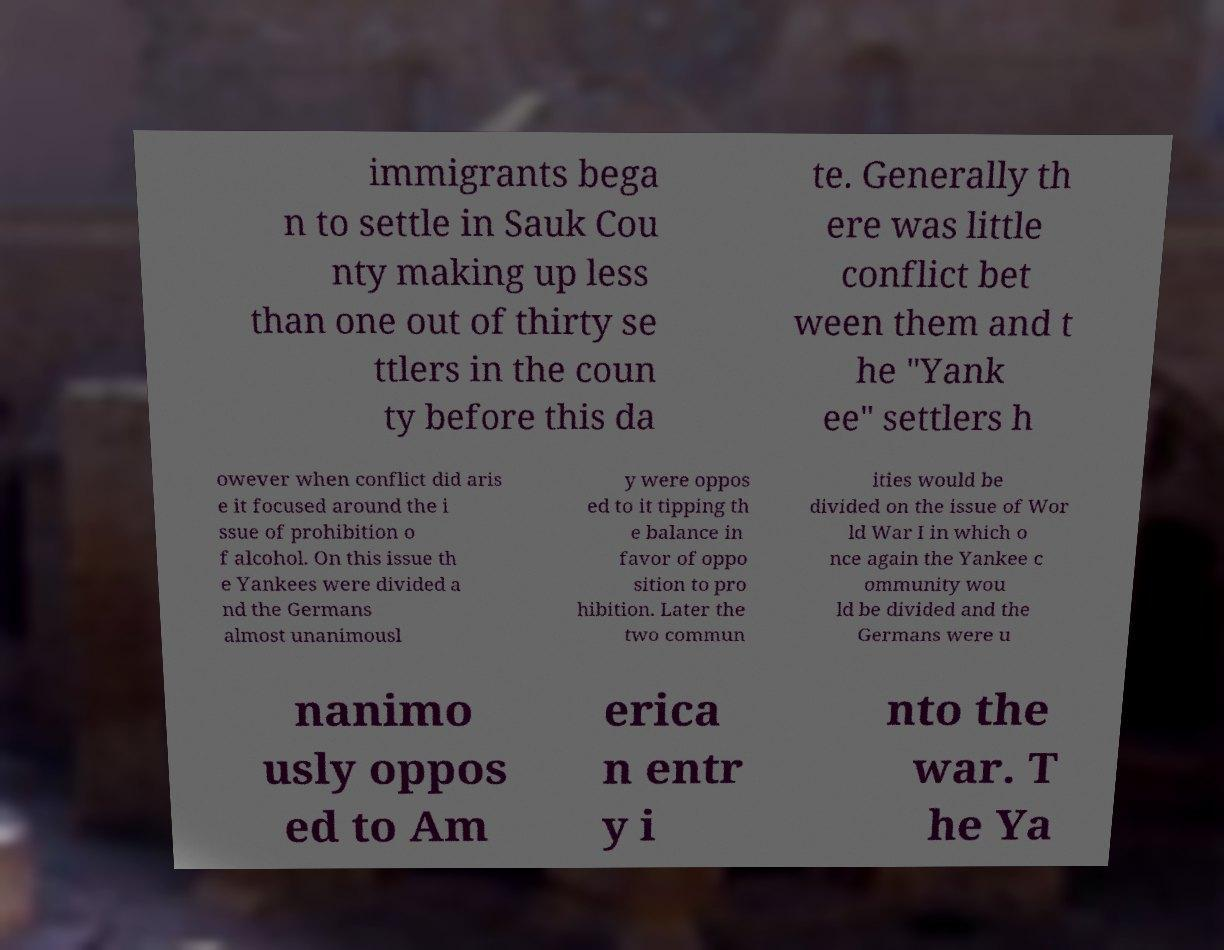There's text embedded in this image that I need extracted. Can you transcribe it verbatim? immigrants bega n to settle in Sauk Cou nty making up less than one out of thirty se ttlers in the coun ty before this da te. Generally th ere was little conflict bet ween them and t he "Yank ee" settlers h owever when conflict did aris e it focused around the i ssue of prohibition o f alcohol. On this issue th e Yankees were divided a nd the Germans almost unanimousl y were oppos ed to it tipping th e balance in favor of oppo sition to pro hibition. Later the two commun ities would be divided on the issue of Wor ld War I in which o nce again the Yankee c ommunity wou ld be divided and the Germans were u nanimo usly oppos ed to Am erica n entr y i nto the war. T he Ya 